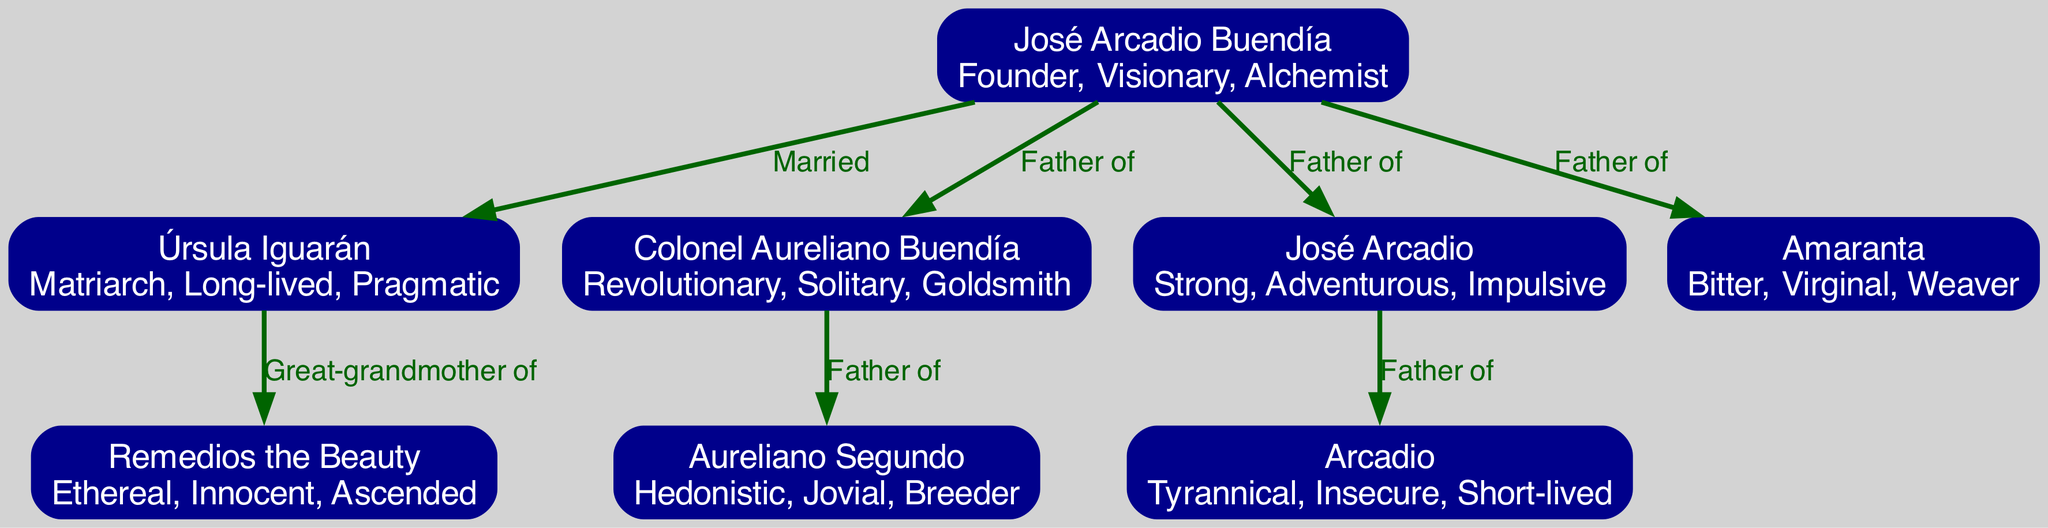What is the relationship between José Arcadio Buendía and Úrsula Iguarán? According to the diagram, José Arcadio Buendía is married to Úrsula Iguarán, which is explicitly stated by the label on the edge connecting the two nodes.
Answer: Married How many children did José Arcadio Buendía have? The diagram shows that José Arcadio Buendía has three children indicated by the edges connecting him to Colonel Aureliano Buendía, José Arcadio, and Amaranta.
Answer: Three Which character is described as "Ethereal, Innocent, Ascended"? Looking at the diagram, Remedios the Beauty has the traits "Ethereal, Innocent, Ascended" listed below her name, making her the character associated with these traits.
Answer: Remedios the Beauty Who is the great-grandmother of Remedios the Beauty? According to the edge connecting Úrsula Iguarán to Remedios the Beauty, Úrsula is described as the great-grandmother of Remedios the Beauty, clarifying her family position.
Answer: Úrsula Iguarán What character trait describes Aureliano Segundo? The diagram indicates that Aureliano Segundo has the traits "Hedonistic, Jovial, Breeder," directly associated with his node, providing a clear answer.
Answer: Hedonistic, Jovial, Breeder What is the connection between José Arcadio and Arcadio? The relationship is specified in the diagram where an edge labeled "Father of" links José Arcadio to Arcadio, defining a direct father-son relationship.
Answer: Father of How many generations are represented in the Buendía family tree? From the diagram, we can observe that there are four generations represented: José Arcadio Buendía and Úrsula Iguarán as the founders, their children, and their grandchildren, including Remedios the Beauty. Hence, counting them gives four generations.
Answer: Four Which character is both a Revolutionary and Solitary? The diagram notes that Colonel Aureliano Buendía is described with the traits "Revolutionary, Solitary, Goldsmith," which directly identifies him as the character in question.
Answer: Colonel Aureliano Buendía How many nodes are connected to José Arcadio Buendía? The diagram shows that José Arcadio Buendía is connected to four nodes: Úrsula Iguarán, Colonel Aureliano Buendía, José Arcadio, and Amaranta, indicating the number of direct connections he has.
Answer: Four 